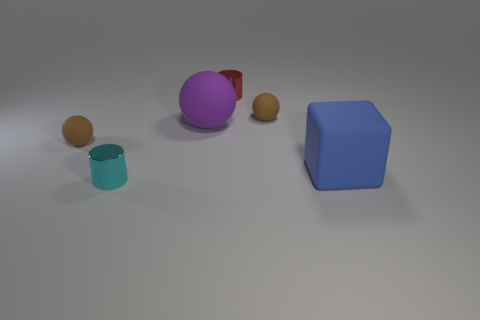Subtract all large rubber spheres. How many spheres are left? 2 Subtract all cyan blocks. How many brown balls are left? 2 Add 3 red cylinders. How many objects exist? 9 Subtract all blocks. How many objects are left? 5 Subtract all green spheres. Subtract all gray cylinders. How many spheres are left? 3 Subtract 0 green blocks. How many objects are left? 6 Subtract all yellow shiny blocks. Subtract all tiny brown matte things. How many objects are left? 4 Add 2 small brown rubber balls. How many small brown rubber balls are left? 4 Add 2 big blue metallic cubes. How many big blue metallic cubes exist? 2 